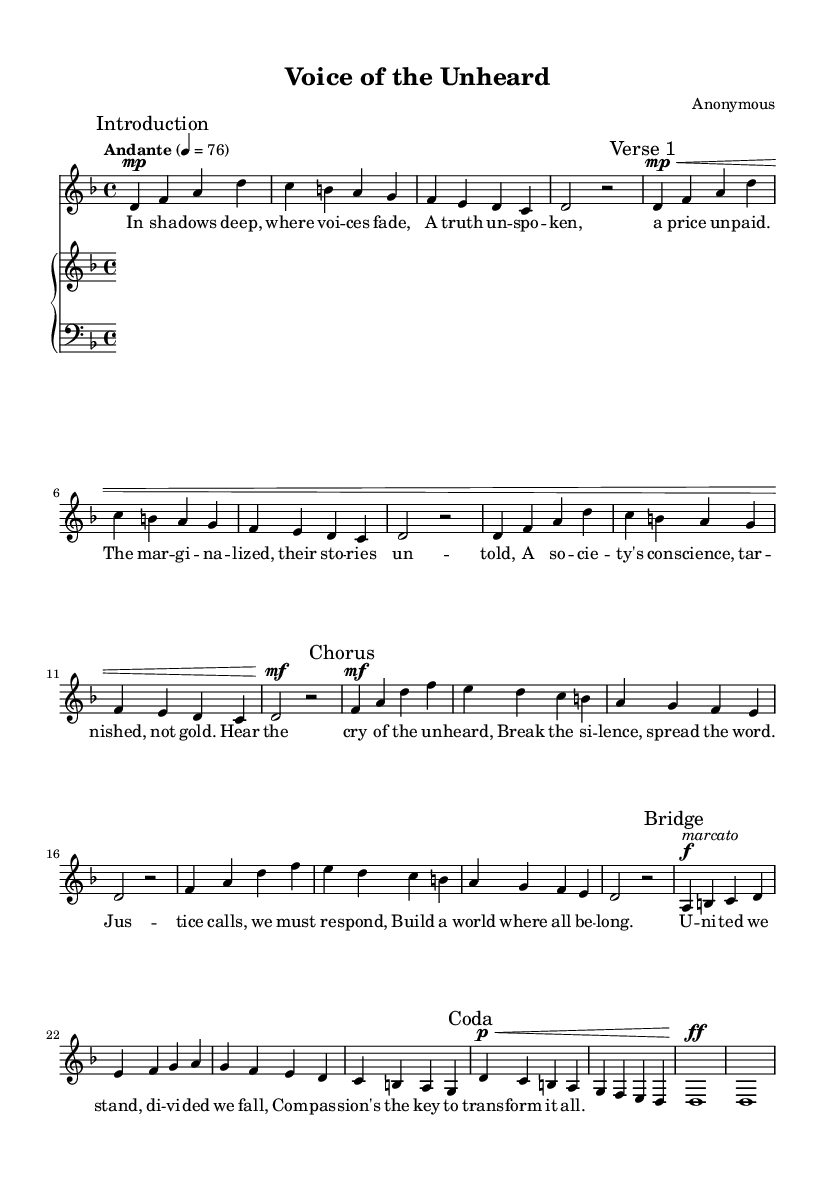What is the key signature of this music? The key signature is indicated in the global settings. In this case, it specifies D minor, which has one flat (B flat).
Answer: D minor What is the time signature of this piece? The time signature is found in the global settings. It is written as "4/4," indicating there are four beats in each measure.
Answer: 4/4 What is the tempo marking of the music? The tempo is noted as "Andante" with a beat of 76. This indicates a moderate walking pace.
Answer: Andante How many verses are there in this composition? The structure includes an "Introduction," followed by "Verse 1," a "Chorus," a "Bridge," and a "Coda." Counting these sections, there is one verse specified.
Answer: 1 What dynamic marking appears with the bridge section? The dynamic marking occurring in the bridge section is marked as "f" (forte), which indicates it should be played loudly.
Answer: forte In which part of the music do we first see lyrics that discuss social issues? The lyrics addressing social issues first appear in "Verse 1" with lines emphasizing marginalized voices and unspoken truths.
Answer: Verse 1 What does "mp" indicate in the music? The "mp" marking stands for "mediopiano," indicating a moderately soft volume. This marking appears at the beginning of the "Verse 1" section.
Answer: mediopiano 